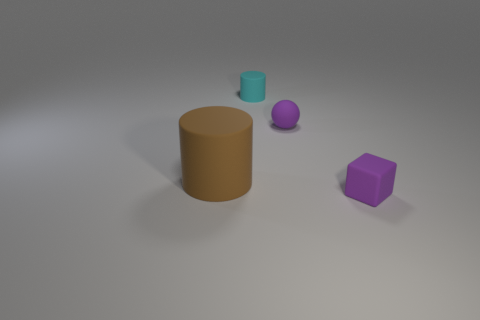Can you describe the lighting and shadow in this scene? The scene is softly lit from above, casting gentle shadows to the right of the objects which implies that the primary light source is to the top left of the scene. The softness of the shadows suggests a diffused light source, creating a calm and evenly lit arrangement without harsh contrasts. 